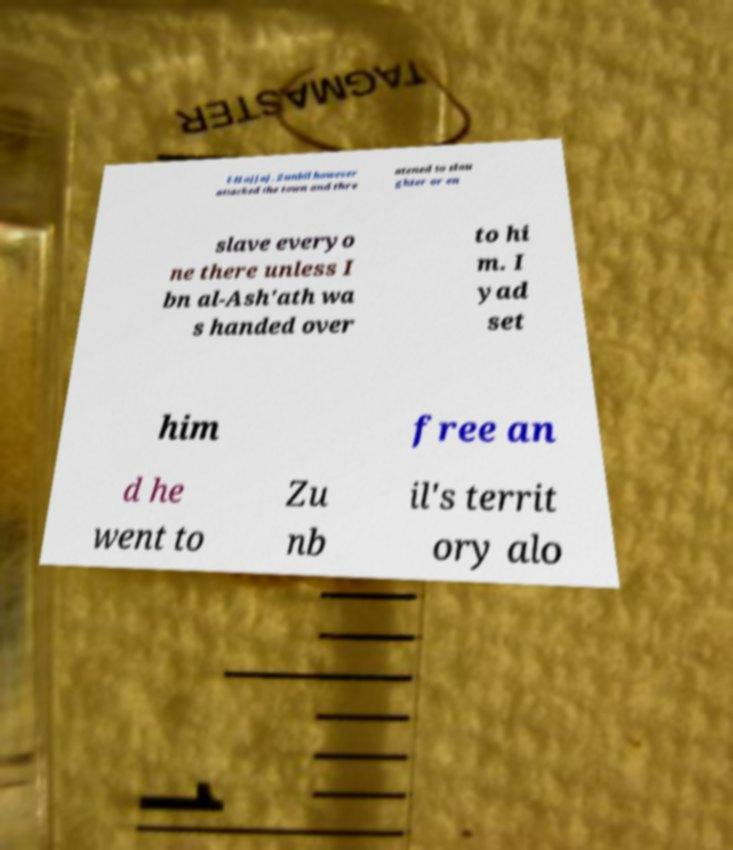Can you accurately transcribe the text from the provided image for me? l-Hajjaj. Zunbil however attacked the town and thre atened to slau ghter or en slave everyo ne there unless I bn al-Ash'ath wa s handed over to hi m. I yad set him free an d he went to Zu nb il's territ ory alo 